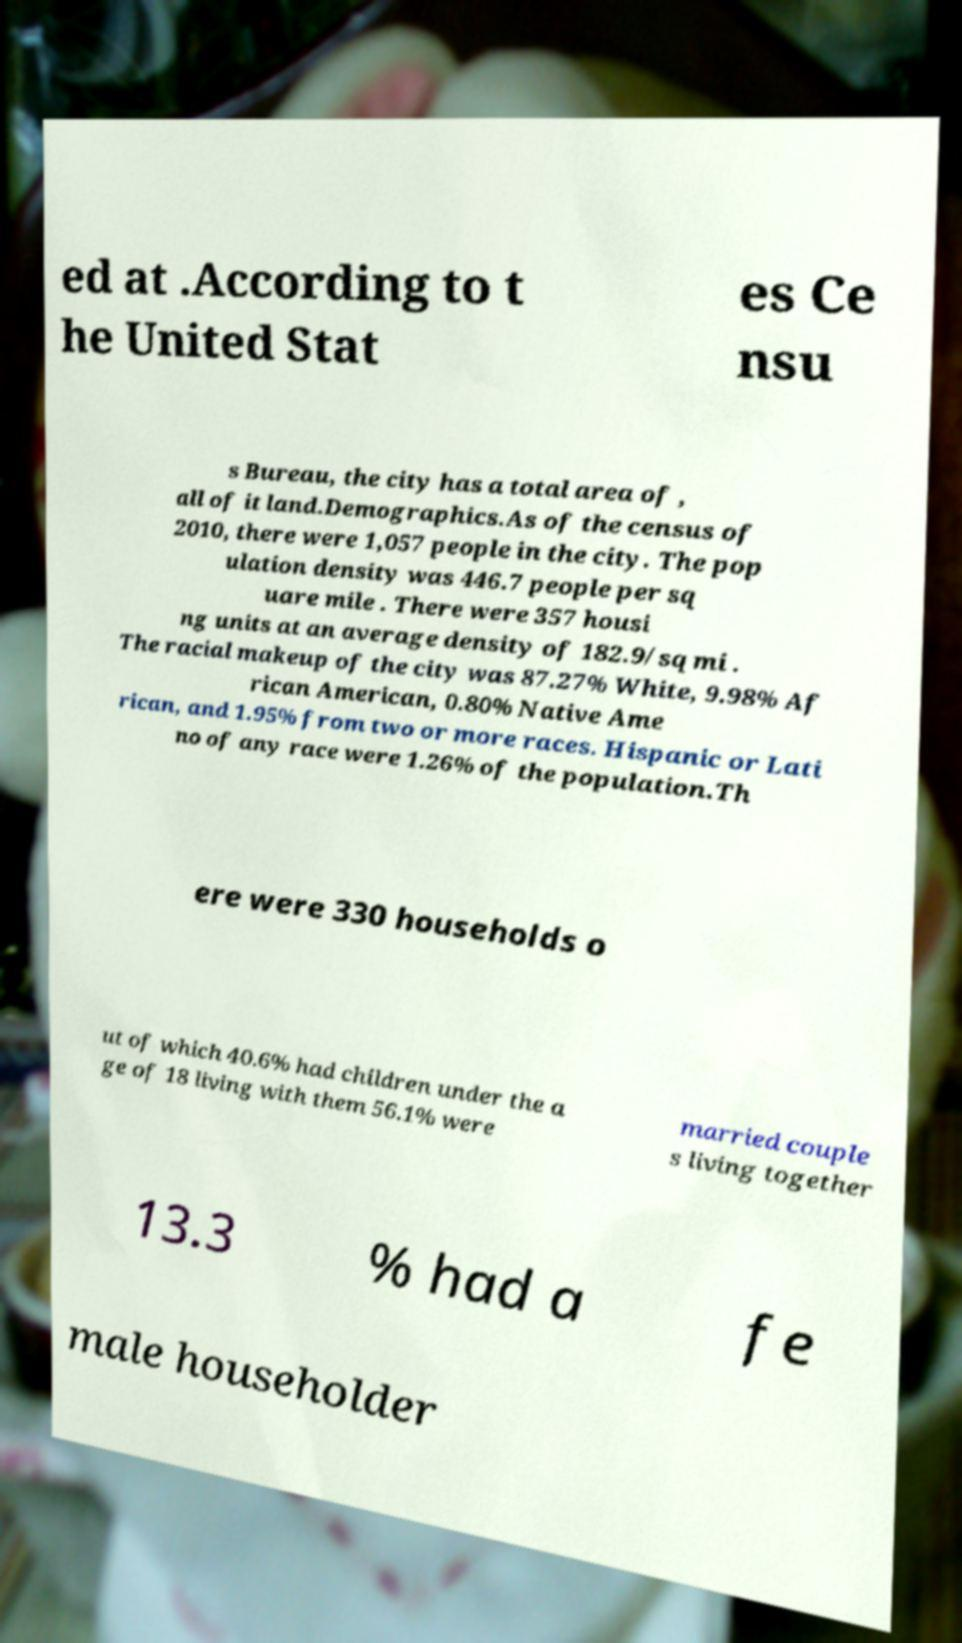Can you read and provide the text displayed in the image?This photo seems to have some interesting text. Can you extract and type it out for me? ed at .According to t he United Stat es Ce nsu s Bureau, the city has a total area of , all of it land.Demographics.As of the census of 2010, there were 1,057 people in the city. The pop ulation density was 446.7 people per sq uare mile . There were 357 housi ng units at an average density of 182.9/sq mi . The racial makeup of the city was 87.27% White, 9.98% Af rican American, 0.80% Native Ame rican, and 1.95% from two or more races. Hispanic or Lati no of any race were 1.26% of the population.Th ere were 330 households o ut of which 40.6% had children under the a ge of 18 living with them 56.1% were married couple s living together 13.3 % had a fe male householder 